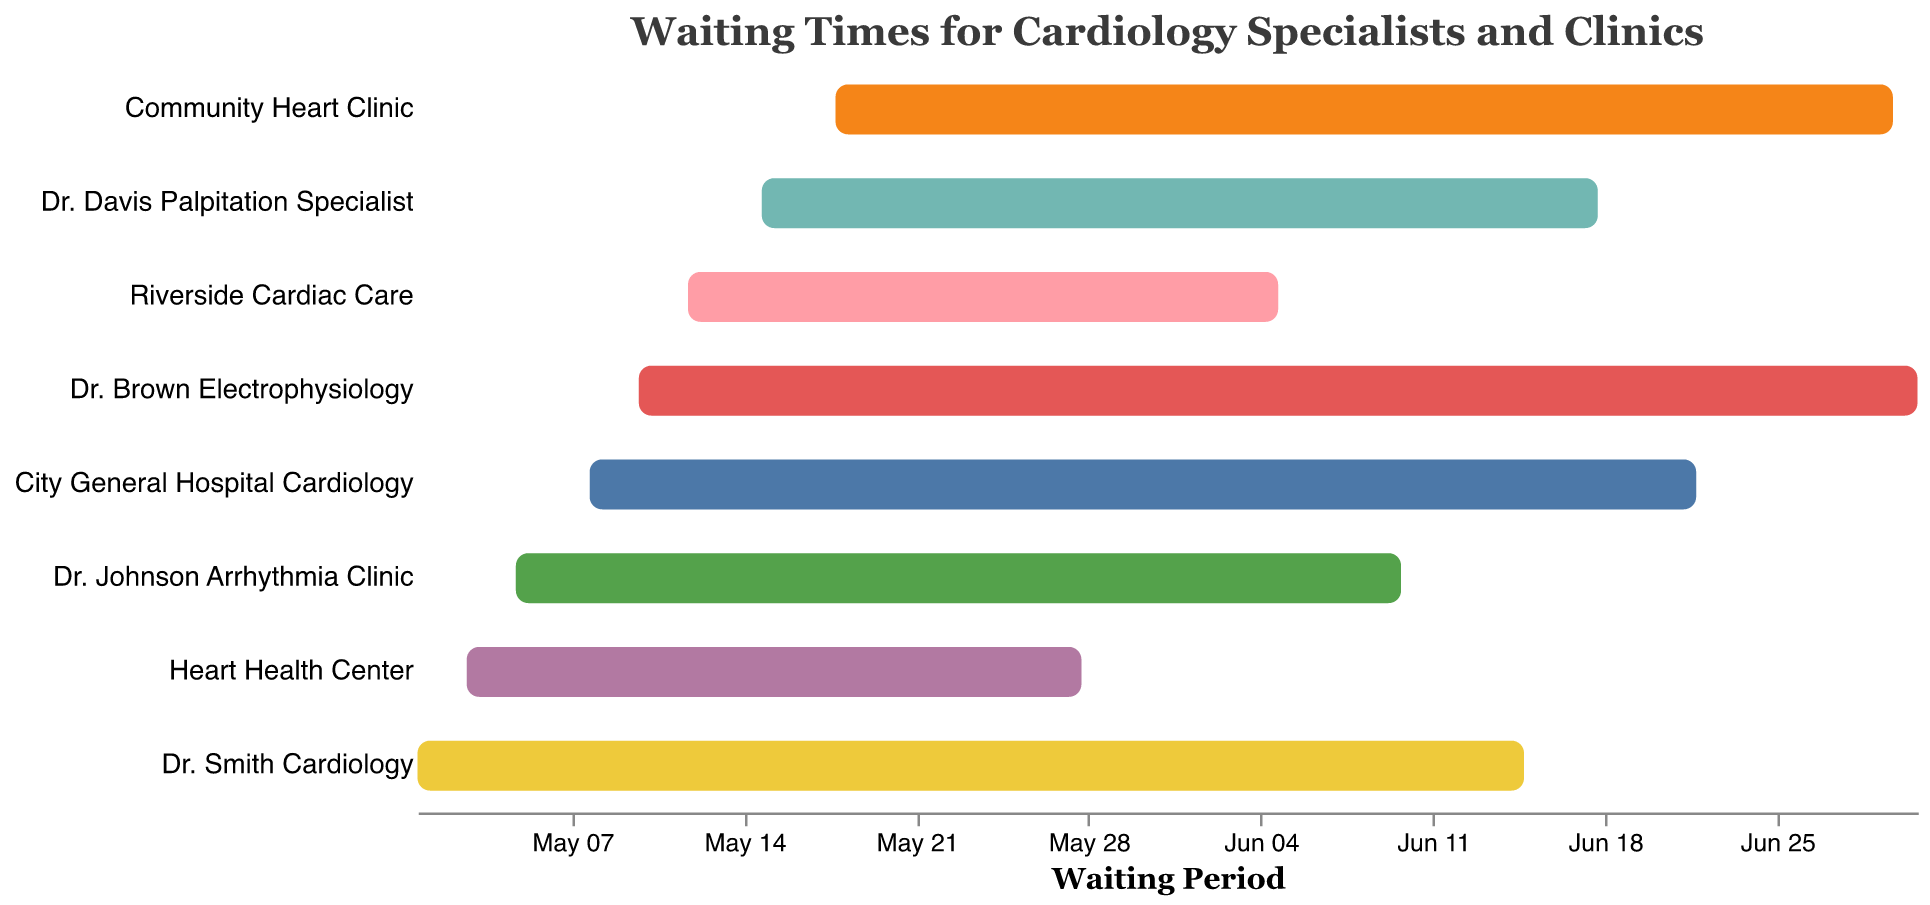What is the title of the chart? The title of the chart is usually found at the top and it provides a concise summary of what the chart is about. Here, the title reads "Waiting Times for Cardiology Specialists and Clinics".
Answer: Waiting Times for Cardiology Specialists and Clinics Which clinic has the shortest waiting time? To determine the shortest waiting time, you need to compare the time spans represented by the bars in the chart. The Heart Health Center has the shortest waiting time from May 3 to May 28.
Answer: Heart Health Center What is the waiting period for Dr. Davis Palpitation Specialist? Dr. Davis Palpitation Specialist has a bar that starts on May 15 and ends on June 18. Counting the days in this interval, the waiting period is from May 15 to June 18.
Answer: May 15 to June 18 Which clinic starts accepting appointments the earliest? To find this, we need to look at the start dates of all the bars in the chart. Dr. Smith Cardiology starts the earliest on May 1st.
Answer: Dr. Smith Cardiology How long is the waiting period for Community Heart Clinic compared to Dr. Brown Electrophysiology? First, note the start and end dates for Community Heart Clinic (May 18 to June 30) and Dr. Brown Electrophysiology (May 10 to July 1). Calculating the number of days for both: Community Heart Clinic = 43 days, Dr. Brown Electrophysiology = 53 days.
Answer: Community Heart Clinic: 43 days, Dr. Brown Electrophysiology: 53 days Which specialist/clinic has the longest waiting time? Identify the bar with the longest waiting period by measuring from the start date to the end date. Dr. Brown Electrophysiology has the longest waiting time from May 10 to July 1.
Answer: Dr. Brown Electrophysiology What is the average waiting period across all clinics? First, calculate the waiting periods for all clinics: Dr. Smith Cardiology = 45 days, Heart Health Center = 25 days, Dr. Johnson Arrhythmia Clinic = 36 days, City General Hospital Cardiology = 45 days, Dr. Brown Electrophysiology = 53 days, Riverside Cardiac Care = 24 days, Dr. Davis Palpitation Specialist = 34 days, Community Heart Clinic = 43 days. Summing these and dividing by the number of clinics (8) gives the average: (45+25+36+45+53+24+34+43)/8 = 38.125 days.
Answer: 38.125 days Which two clinics have the closest waiting periods? Calculate and compare the waiting periods for all clinics. Dr. Smith Cardiology and City General Hospital Cardiology both have a waiting period of 45 days.
Answer: Dr. Smith Cardiology and City General Hospital Cardiology 